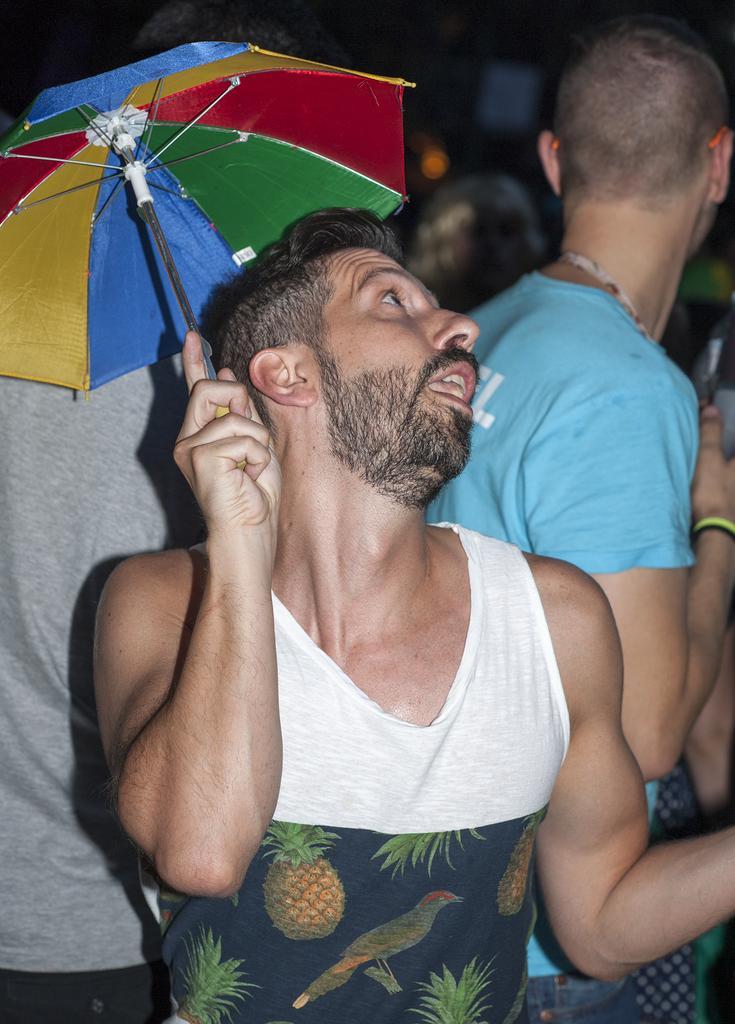In one or two sentences, can you explain what this image depicts? In this image in the foreground I can see a man holding an umbrella. 